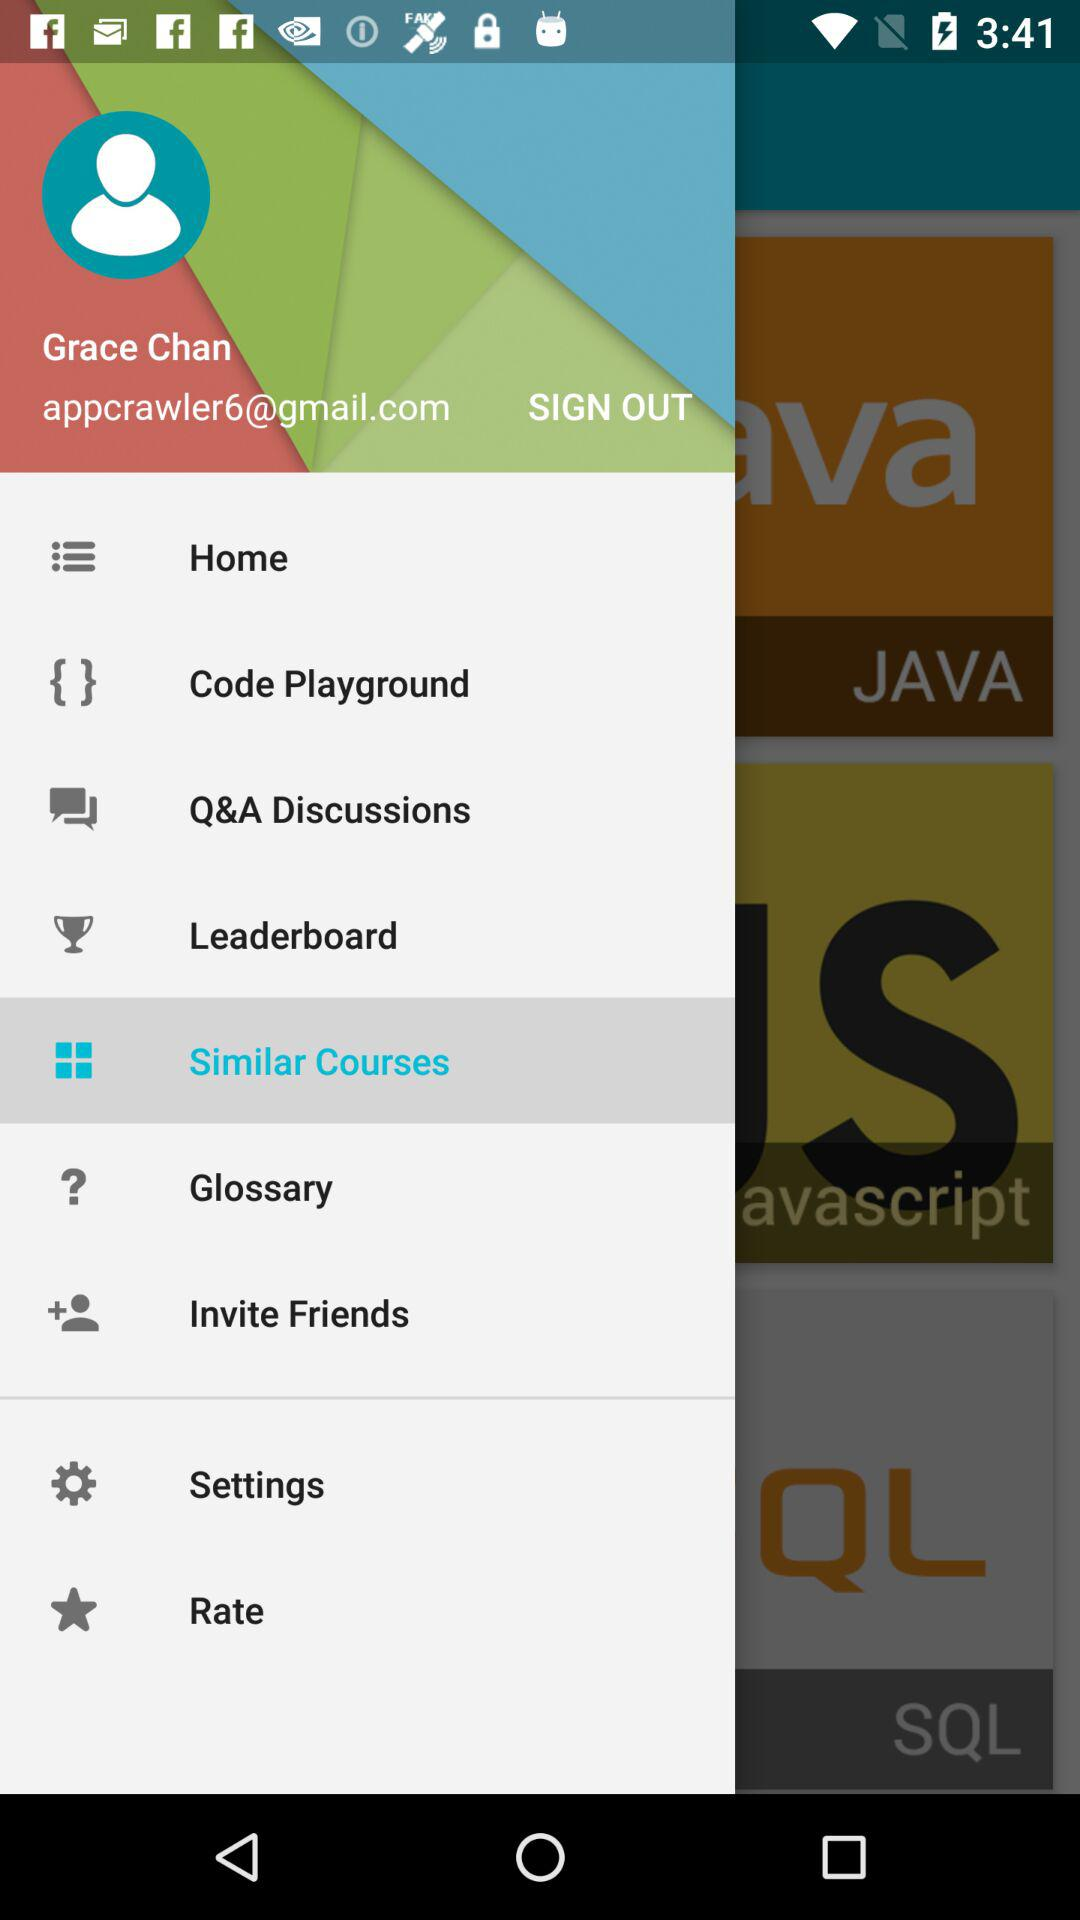Which item is selected? The selected item is "Similar Courses". 